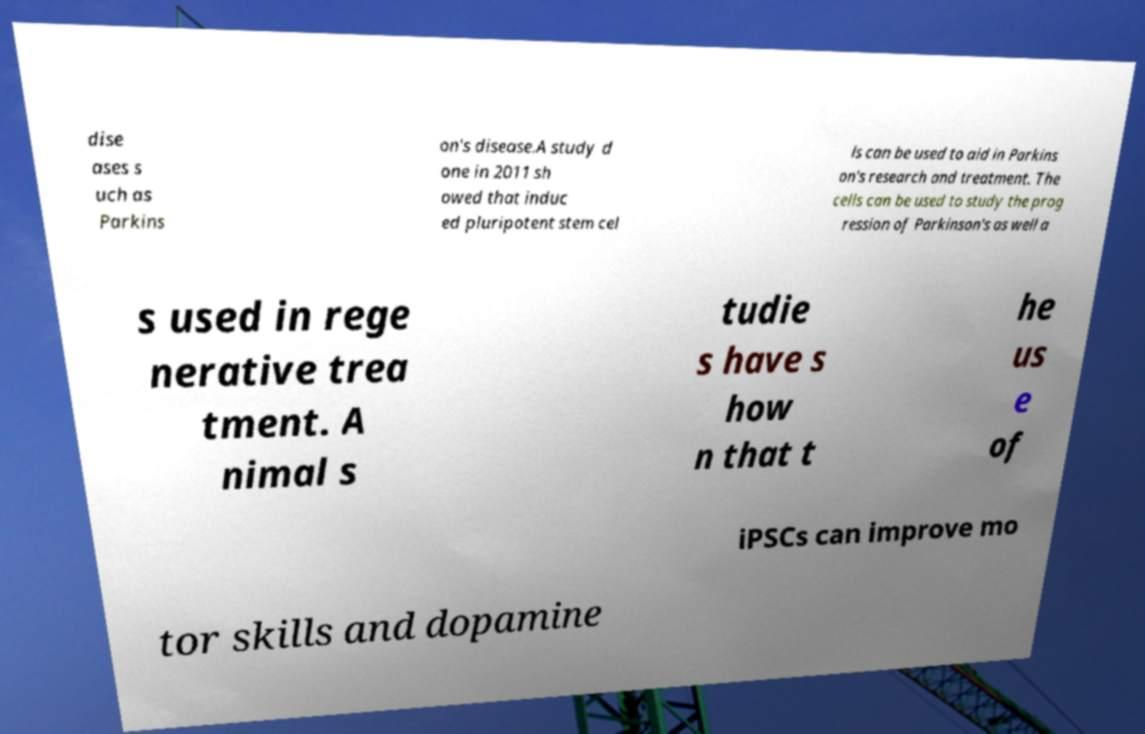Could you extract and type out the text from this image? dise ases s uch as Parkins on's disease.A study d one in 2011 sh owed that induc ed pluripotent stem cel ls can be used to aid in Parkins on's research and treatment. The cells can be used to study the prog ression of Parkinson's as well a s used in rege nerative trea tment. A nimal s tudie s have s how n that t he us e of iPSCs can improve mo tor skills and dopamine 